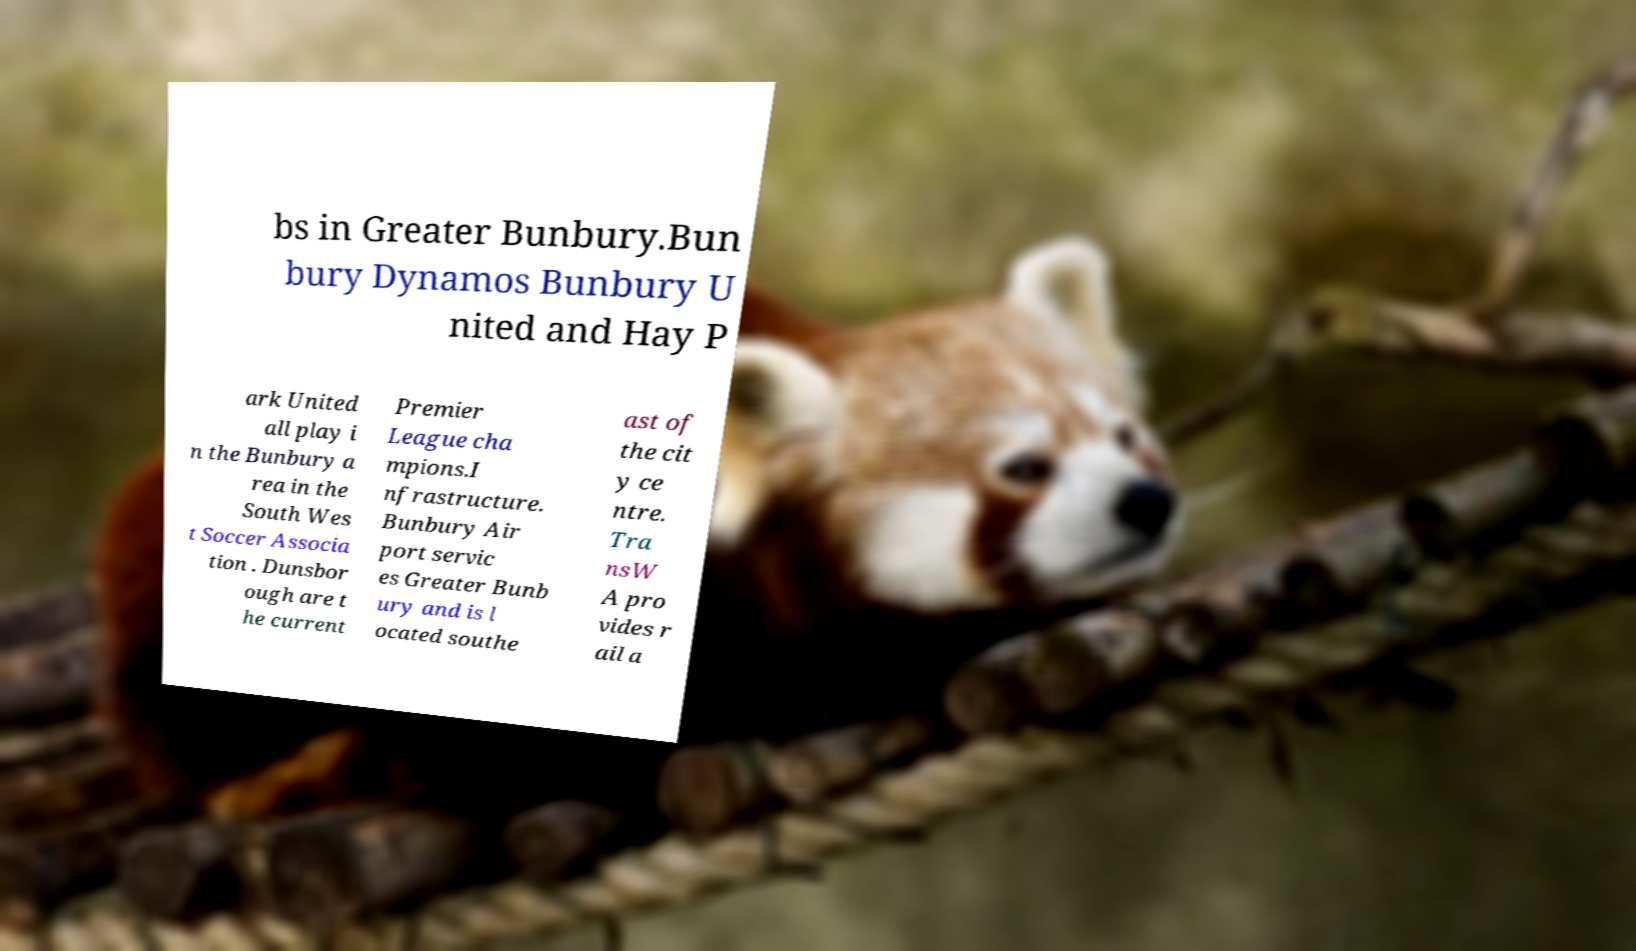What messages or text are displayed in this image? I need them in a readable, typed format. bs in Greater Bunbury.Bun bury Dynamos Bunbury U nited and Hay P ark United all play i n the Bunbury a rea in the South Wes t Soccer Associa tion . Dunsbor ough are t he current Premier League cha mpions.I nfrastructure. Bunbury Air port servic es Greater Bunb ury and is l ocated southe ast of the cit y ce ntre. Tra nsW A pro vides r ail a 